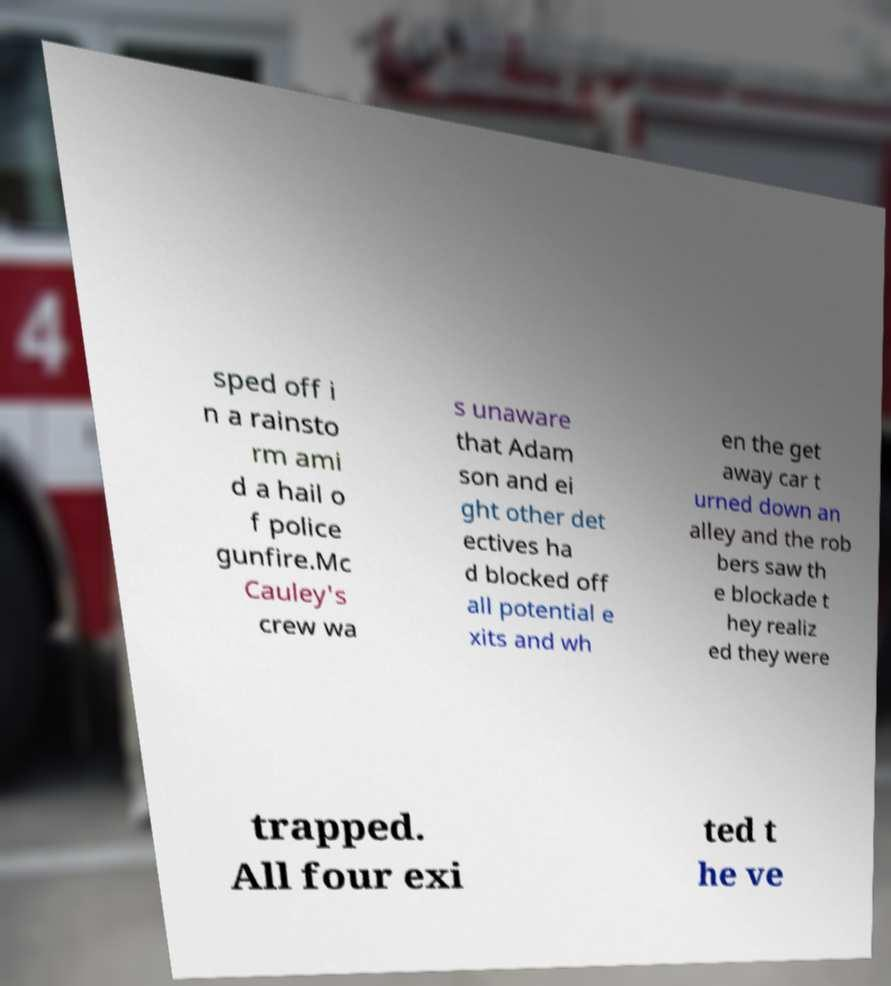Please identify and transcribe the text found in this image. sped off i n a rainsto rm ami d a hail o f police gunfire.Mc Cauley's crew wa s unaware that Adam son and ei ght other det ectives ha d blocked off all potential e xits and wh en the get away car t urned down an alley and the rob bers saw th e blockade t hey realiz ed they were trapped. All four exi ted t he ve 